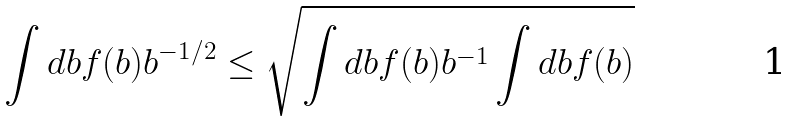<formula> <loc_0><loc_0><loc_500><loc_500>\int d b f ( b ) b ^ { - 1 / 2 } \leq \sqrt { \int d b f ( b ) b ^ { - 1 } \int d b f ( b ) }</formula> 